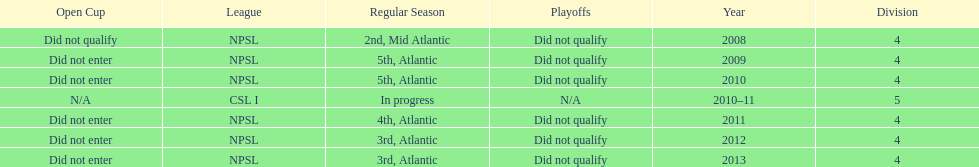Using the data, what should be the next year they will play? 2014. 